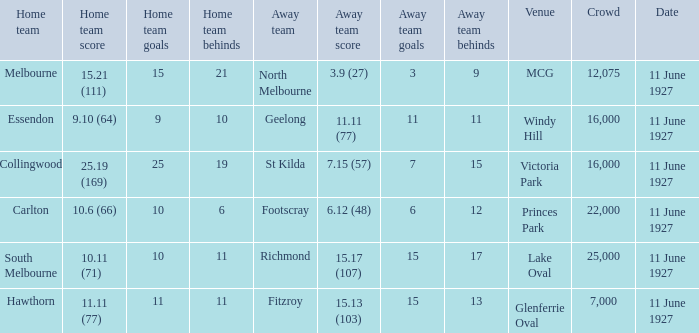What is the sum of all crowds present at the Glenferrie Oval venue? 7000.0. 